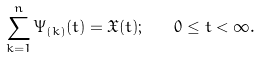<formula> <loc_0><loc_0><loc_500><loc_500>\sum _ { k = 1 } ^ { n } \Psi _ { ( k ) } ( t ) = \mathfrak { X } ( t ) ; \quad 0 \leq t < \infty .</formula> 